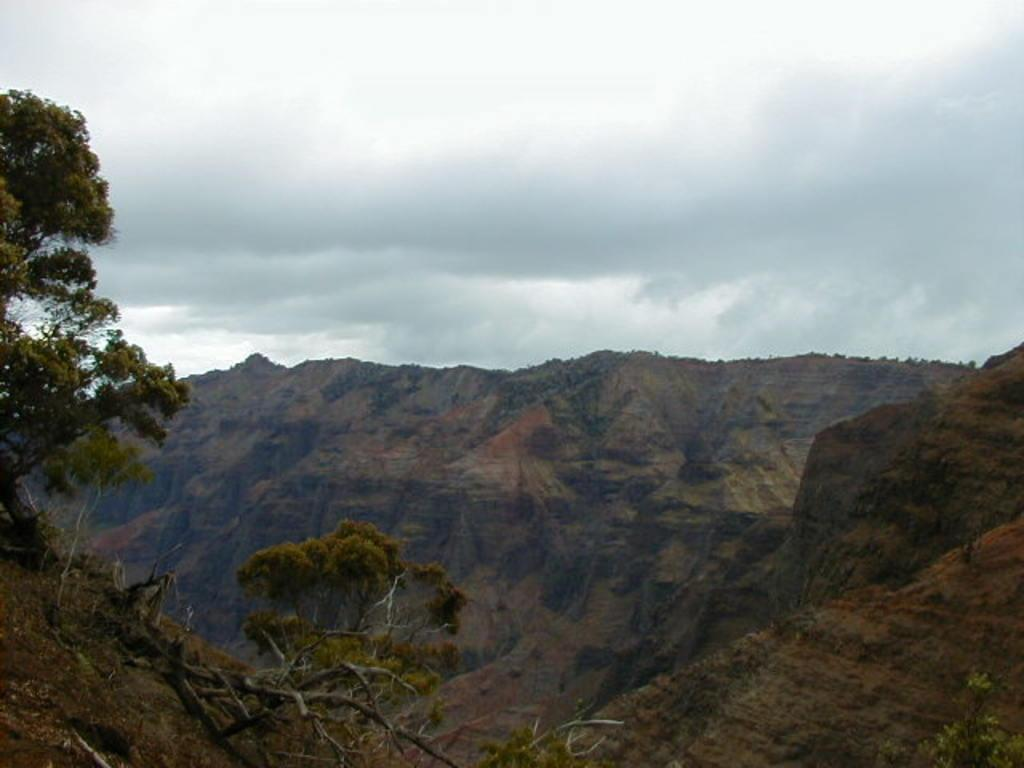What type of vegetation can be seen in the image? There are trees in the image. What is the color of the trees? The trees are green in color. What can be seen in the distance behind the trees? There are mountains visible in the background of the image. What is the color of the sky in the image? The sky is white and gray in color. What type of brush is used to paint the word on the trees in the image? There is no brush or word present in the image; it features trees, mountains, and a sky. 